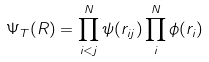Convert formula to latex. <formula><loc_0><loc_0><loc_500><loc_500>\Psi _ { T } ( R ) = \prod _ { i < j } ^ { N } \psi ( r _ { i j } ) \prod _ { i } ^ { N } \phi ( r _ { i } )</formula> 